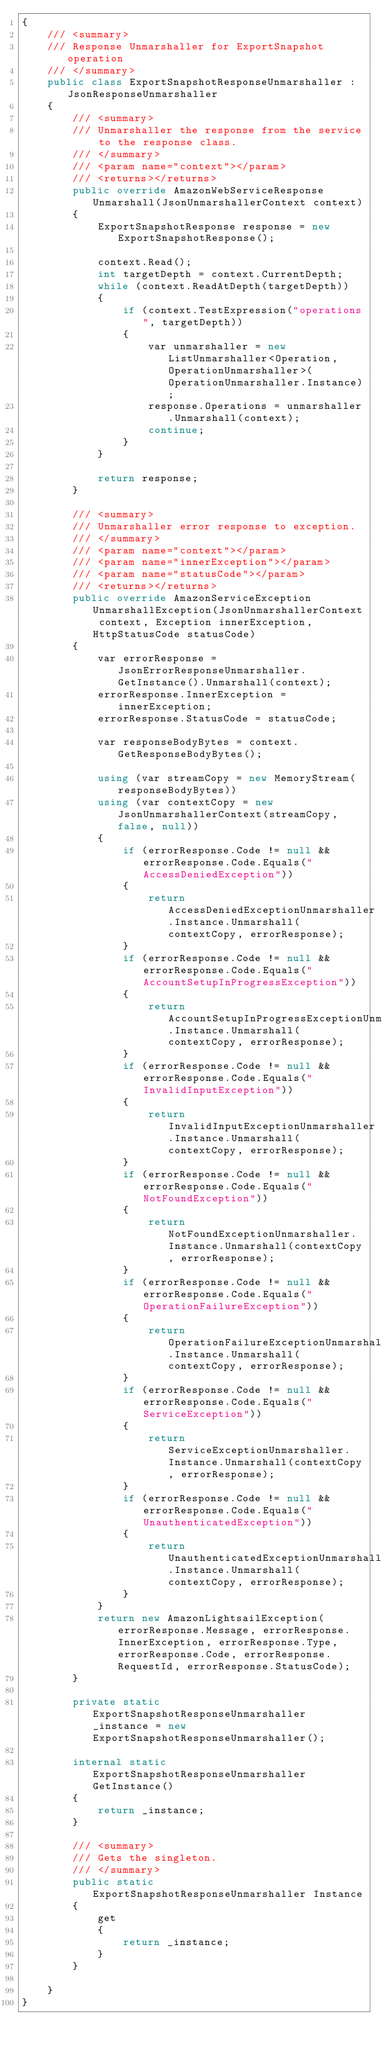<code> <loc_0><loc_0><loc_500><loc_500><_C#_>{
    /// <summary>
    /// Response Unmarshaller for ExportSnapshot operation
    /// </summary>  
    public class ExportSnapshotResponseUnmarshaller : JsonResponseUnmarshaller
    {
        /// <summary>
        /// Unmarshaller the response from the service to the response class.
        /// </summary>  
        /// <param name="context"></param>
        /// <returns></returns>
        public override AmazonWebServiceResponse Unmarshall(JsonUnmarshallerContext context)
        {
            ExportSnapshotResponse response = new ExportSnapshotResponse();

            context.Read();
            int targetDepth = context.CurrentDepth;
            while (context.ReadAtDepth(targetDepth))
            {
                if (context.TestExpression("operations", targetDepth))
                {
                    var unmarshaller = new ListUnmarshaller<Operation, OperationUnmarshaller>(OperationUnmarshaller.Instance);
                    response.Operations = unmarshaller.Unmarshall(context);
                    continue;
                }
            }

            return response;
        }

        /// <summary>
        /// Unmarshaller error response to exception.
        /// </summary>  
        /// <param name="context"></param>
        /// <param name="innerException"></param>
        /// <param name="statusCode"></param>
        /// <returns></returns>
        public override AmazonServiceException UnmarshallException(JsonUnmarshallerContext context, Exception innerException, HttpStatusCode statusCode)
        {
            var errorResponse = JsonErrorResponseUnmarshaller.GetInstance().Unmarshall(context);
            errorResponse.InnerException = innerException;
            errorResponse.StatusCode = statusCode;

            var responseBodyBytes = context.GetResponseBodyBytes();

            using (var streamCopy = new MemoryStream(responseBodyBytes))
            using (var contextCopy = new JsonUnmarshallerContext(streamCopy, false, null))
            {
                if (errorResponse.Code != null && errorResponse.Code.Equals("AccessDeniedException"))
                {
                    return AccessDeniedExceptionUnmarshaller.Instance.Unmarshall(contextCopy, errorResponse);
                }
                if (errorResponse.Code != null && errorResponse.Code.Equals("AccountSetupInProgressException"))
                {
                    return AccountSetupInProgressExceptionUnmarshaller.Instance.Unmarshall(contextCopy, errorResponse);
                }
                if (errorResponse.Code != null && errorResponse.Code.Equals("InvalidInputException"))
                {
                    return InvalidInputExceptionUnmarshaller.Instance.Unmarshall(contextCopy, errorResponse);
                }
                if (errorResponse.Code != null && errorResponse.Code.Equals("NotFoundException"))
                {
                    return NotFoundExceptionUnmarshaller.Instance.Unmarshall(contextCopy, errorResponse);
                }
                if (errorResponse.Code != null && errorResponse.Code.Equals("OperationFailureException"))
                {
                    return OperationFailureExceptionUnmarshaller.Instance.Unmarshall(contextCopy, errorResponse);
                }
                if (errorResponse.Code != null && errorResponse.Code.Equals("ServiceException"))
                {
                    return ServiceExceptionUnmarshaller.Instance.Unmarshall(contextCopy, errorResponse);
                }
                if (errorResponse.Code != null && errorResponse.Code.Equals("UnauthenticatedException"))
                {
                    return UnauthenticatedExceptionUnmarshaller.Instance.Unmarshall(contextCopy, errorResponse);
                }
            }
            return new AmazonLightsailException(errorResponse.Message, errorResponse.InnerException, errorResponse.Type, errorResponse.Code, errorResponse.RequestId, errorResponse.StatusCode);
        }

        private static ExportSnapshotResponseUnmarshaller _instance = new ExportSnapshotResponseUnmarshaller();        

        internal static ExportSnapshotResponseUnmarshaller GetInstance()
        {
            return _instance;
        }

        /// <summary>
        /// Gets the singleton.
        /// </summary>  
        public static ExportSnapshotResponseUnmarshaller Instance
        {
            get
            {
                return _instance;
            }
        }

    }
}</code> 